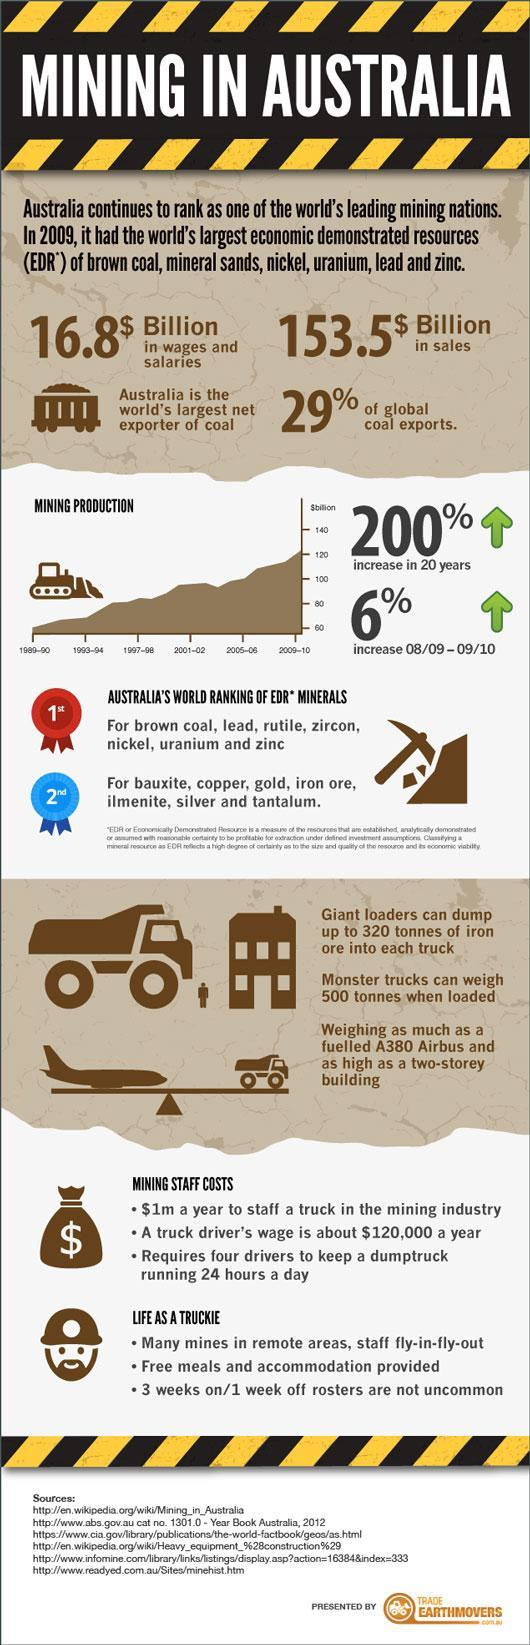How many sources are listed at the bottom?
Answer the question with a short phrase. 6 During which year did mining production go above 120 billion $? 2009-10 